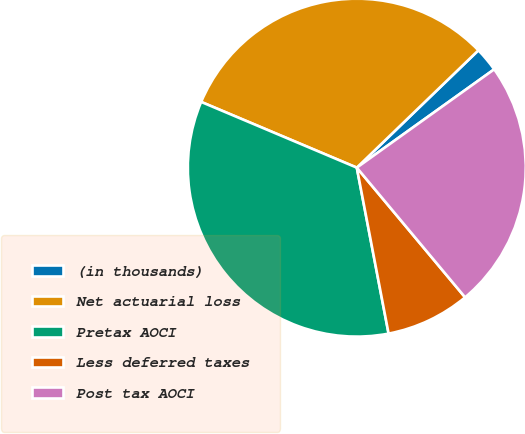Convert chart. <chart><loc_0><loc_0><loc_500><loc_500><pie_chart><fcel>(in thousands)<fcel>Net actuarial loss<fcel>Pretax AOCI<fcel>Less deferred taxes<fcel>Post tax AOCI<nl><fcel>2.33%<fcel>31.42%<fcel>34.37%<fcel>8.06%<fcel>23.81%<nl></chart> 